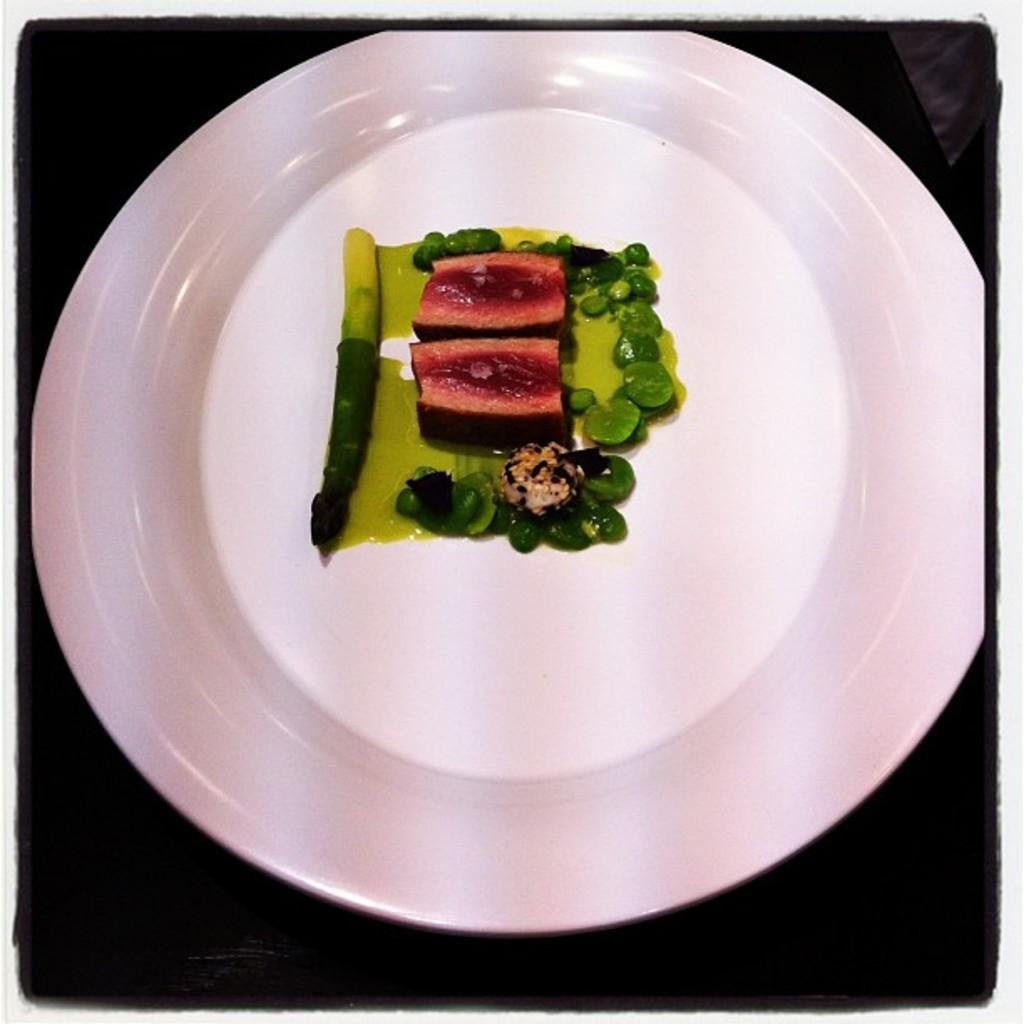What is the color of the plate in the image? The plate in the image is white. What type of food item can be seen on the plate? There is a green and red color food item on the plate. What type of weather can be seen in the image? There is no weather visible in the image, as it only shows a white plate with a green and red color food item on it. 